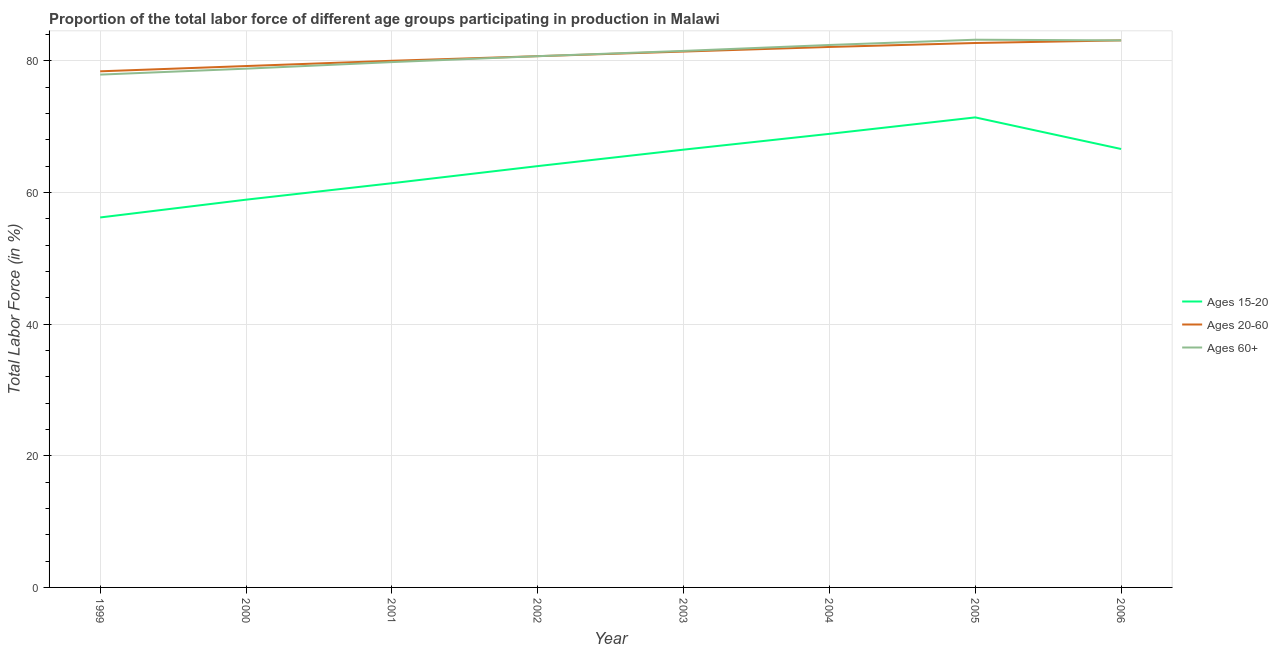How many different coloured lines are there?
Your answer should be very brief. 3. Does the line corresponding to percentage of labor force within the age group 15-20 intersect with the line corresponding to percentage of labor force above age 60?
Make the answer very short. No. What is the percentage of labor force within the age group 15-20 in 2006?
Your response must be concise. 66.6. Across all years, what is the maximum percentage of labor force within the age group 20-60?
Offer a terse response. 83.1. Across all years, what is the minimum percentage of labor force within the age group 20-60?
Your answer should be compact. 78.4. In which year was the percentage of labor force above age 60 maximum?
Your response must be concise. 2005. What is the total percentage of labor force within the age group 20-60 in the graph?
Your response must be concise. 647.6. What is the difference between the percentage of labor force within the age group 20-60 in 2002 and that in 2006?
Provide a short and direct response. -2.4. What is the difference between the percentage of labor force above age 60 in 2006 and the percentage of labor force within the age group 20-60 in 2000?
Make the answer very short. 3.9. What is the average percentage of labor force within the age group 20-60 per year?
Keep it short and to the point. 80.95. What is the ratio of the percentage of labor force within the age group 15-20 in 2000 to that in 2006?
Provide a short and direct response. 0.88. Is the difference between the percentage of labor force above age 60 in 2004 and 2005 greater than the difference between the percentage of labor force within the age group 15-20 in 2004 and 2005?
Ensure brevity in your answer.  Yes. What is the difference between the highest and the second highest percentage of labor force above age 60?
Offer a very short reply. 0.1. What is the difference between the highest and the lowest percentage of labor force above age 60?
Keep it short and to the point. 5.3. Is it the case that in every year, the sum of the percentage of labor force within the age group 15-20 and percentage of labor force within the age group 20-60 is greater than the percentage of labor force above age 60?
Make the answer very short. Yes. Does the percentage of labor force within the age group 15-20 monotonically increase over the years?
Provide a short and direct response. No. Is the percentage of labor force within the age group 15-20 strictly greater than the percentage of labor force above age 60 over the years?
Your answer should be very brief. No. How many lines are there?
Offer a very short reply. 3. How many years are there in the graph?
Make the answer very short. 8. Are the values on the major ticks of Y-axis written in scientific E-notation?
Make the answer very short. No. Does the graph contain any zero values?
Your response must be concise. No. Does the graph contain grids?
Offer a terse response. Yes. How are the legend labels stacked?
Make the answer very short. Vertical. What is the title of the graph?
Offer a very short reply. Proportion of the total labor force of different age groups participating in production in Malawi. Does "Refusal of sex" appear as one of the legend labels in the graph?
Keep it short and to the point. No. What is the Total Labor Force (in %) in Ages 15-20 in 1999?
Make the answer very short. 56.2. What is the Total Labor Force (in %) of Ages 20-60 in 1999?
Your answer should be compact. 78.4. What is the Total Labor Force (in %) of Ages 60+ in 1999?
Your response must be concise. 77.9. What is the Total Labor Force (in %) of Ages 15-20 in 2000?
Offer a very short reply. 58.9. What is the Total Labor Force (in %) of Ages 20-60 in 2000?
Give a very brief answer. 79.2. What is the Total Labor Force (in %) in Ages 60+ in 2000?
Your answer should be compact. 78.8. What is the Total Labor Force (in %) in Ages 15-20 in 2001?
Your answer should be compact. 61.4. What is the Total Labor Force (in %) of Ages 60+ in 2001?
Give a very brief answer. 79.8. What is the Total Labor Force (in %) of Ages 20-60 in 2002?
Your answer should be very brief. 80.7. What is the Total Labor Force (in %) in Ages 60+ in 2002?
Give a very brief answer. 80.7. What is the Total Labor Force (in %) of Ages 15-20 in 2003?
Offer a very short reply. 66.5. What is the Total Labor Force (in %) in Ages 20-60 in 2003?
Provide a short and direct response. 81.4. What is the Total Labor Force (in %) of Ages 60+ in 2003?
Keep it short and to the point. 81.5. What is the Total Labor Force (in %) in Ages 15-20 in 2004?
Your response must be concise. 68.9. What is the Total Labor Force (in %) of Ages 20-60 in 2004?
Your response must be concise. 82.1. What is the Total Labor Force (in %) in Ages 60+ in 2004?
Your answer should be very brief. 82.4. What is the Total Labor Force (in %) in Ages 15-20 in 2005?
Your response must be concise. 71.4. What is the Total Labor Force (in %) of Ages 20-60 in 2005?
Offer a terse response. 82.7. What is the Total Labor Force (in %) of Ages 60+ in 2005?
Your answer should be compact. 83.2. What is the Total Labor Force (in %) in Ages 15-20 in 2006?
Ensure brevity in your answer.  66.6. What is the Total Labor Force (in %) in Ages 20-60 in 2006?
Your answer should be very brief. 83.1. What is the Total Labor Force (in %) in Ages 60+ in 2006?
Your response must be concise. 83.1. Across all years, what is the maximum Total Labor Force (in %) of Ages 15-20?
Give a very brief answer. 71.4. Across all years, what is the maximum Total Labor Force (in %) in Ages 20-60?
Make the answer very short. 83.1. Across all years, what is the maximum Total Labor Force (in %) in Ages 60+?
Provide a succinct answer. 83.2. Across all years, what is the minimum Total Labor Force (in %) of Ages 15-20?
Your response must be concise. 56.2. Across all years, what is the minimum Total Labor Force (in %) in Ages 20-60?
Keep it short and to the point. 78.4. Across all years, what is the minimum Total Labor Force (in %) of Ages 60+?
Keep it short and to the point. 77.9. What is the total Total Labor Force (in %) of Ages 15-20 in the graph?
Make the answer very short. 513.9. What is the total Total Labor Force (in %) in Ages 20-60 in the graph?
Offer a terse response. 647.6. What is the total Total Labor Force (in %) of Ages 60+ in the graph?
Keep it short and to the point. 647.4. What is the difference between the Total Labor Force (in %) of Ages 20-60 in 1999 and that in 2000?
Keep it short and to the point. -0.8. What is the difference between the Total Labor Force (in %) in Ages 60+ in 1999 and that in 2000?
Ensure brevity in your answer.  -0.9. What is the difference between the Total Labor Force (in %) of Ages 15-20 in 1999 and that in 2001?
Your response must be concise. -5.2. What is the difference between the Total Labor Force (in %) of Ages 20-60 in 1999 and that in 2001?
Ensure brevity in your answer.  -1.6. What is the difference between the Total Labor Force (in %) in Ages 15-20 in 1999 and that in 2002?
Your answer should be compact. -7.8. What is the difference between the Total Labor Force (in %) in Ages 60+ in 1999 and that in 2002?
Your response must be concise. -2.8. What is the difference between the Total Labor Force (in %) in Ages 15-20 in 1999 and that in 2003?
Provide a succinct answer. -10.3. What is the difference between the Total Labor Force (in %) in Ages 20-60 in 1999 and that in 2003?
Make the answer very short. -3. What is the difference between the Total Labor Force (in %) in Ages 60+ in 1999 and that in 2003?
Ensure brevity in your answer.  -3.6. What is the difference between the Total Labor Force (in %) in Ages 15-20 in 1999 and that in 2004?
Keep it short and to the point. -12.7. What is the difference between the Total Labor Force (in %) in Ages 15-20 in 1999 and that in 2005?
Make the answer very short. -15.2. What is the difference between the Total Labor Force (in %) of Ages 15-20 in 1999 and that in 2006?
Offer a very short reply. -10.4. What is the difference between the Total Labor Force (in %) in Ages 20-60 in 2000 and that in 2001?
Keep it short and to the point. -0.8. What is the difference between the Total Labor Force (in %) of Ages 15-20 in 2000 and that in 2002?
Provide a short and direct response. -5.1. What is the difference between the Total Labor Force (in %) of Ages 20-60 in 2000 and that in 2002?
Your answer should be very brief. -1.5. What is the difference between the Total Labor Force (in %) in Ages 15-20 in 2000 and that in 2003?
Give a very brief answer. -7.6. What is the difference between the Total Labor Force (in %) in Ages 20-60 in 2000 and that in 2003?
Offer a very short reply. -2.2. What is the difference between the Total Labor Force (in %) in Ages 15-20 in 2000 and that in 2004?
Ensure brevity in your answer.  -10. What is the difference between the Total Labor Force (in %) in Ages 20-60 in 2000 and that in 2004?
Ensure brevity in your answer.  -2.9. What is the difference between the Total Labor Force (in %) in Ages 15-20 in 2000 and that in 2005?
Offer a terse response. -12.5. What is the difference between the Total Labor Force (in %) in Ages 15-20 in 2000 and that in 2006?
Your answer should be compact. -7.7. What is the difference between the Total Labor Force (in %) of Ages 20-60 in 2000 and that in 2006?
Provide a short and direct response. -3.9. What is the difference between the Total Labor Force (in %) of Ages 60+ in 2000 and that in 2006?
Your response must be concise. -4.3. What is the difference between the Total Labor Force (in %) in Ages 15-20 in 2001 and that in 2002?
Keep it short and to the point. -2.6. What is the difference between the Total Labor Force (in %) in Ages 60+ in 2001 and that in 2002?
Your answer should be very brief. -0.9. What is the difference between the Total Labor Force (in %) of Ages 15-20 in 2001 and that in 2003?
Offer a very short reply. -5.1. What is the difference between the Total Labor Force (in %) of Ages 20-60 in 2001 and that in 2003?
Your answer should be compact. -1.4. What is the difference between the Total Labor Force (in %) of Ages 20-60 in 2001 and that in 2005?
Make the answer very short. -2.7. What is the difference between the Total Labor Force (in %) in Ages 15-20 in 2001 and that in 2006?
Your answer should be compact. -5.2. What is the difference between the Total Labor Force (in %) of Ages 20-60 in 2002 and that in 2003?
Offer a terse response. -0.7. What is the difference between the Total Labor Force (in %) of Ages 20-60 in 2002 and that in 2004?
Your answer should be very brief. -1.4. What is the difference between the Total Labor Force (in %) in Ages 60+ in 2002 and that in 2004?
Provide a succinct answer. -1.7. What is the difference between the Total Labor Force (in %) of Ages 20-60 in 2002 and that in 2005?
Offer a very short reply. -2. What is the difference between the Total Labor Force (in %) of Ages 60+ in 2002 and that in 2005?
Ensure brevity in your answer.  -2.5. What is the difference between the Total Labor Force (in %) of Ages 20-60 in 2002 and that in 2006?
Keep it short and to the point. -2.4. What is the difference between the Total Labor Force (in %) in Ages 60+ in 2003 and that in 2004?
Offer a terse response. -0.9. What is the difference between the Total Labor Force (in %) of Ages 20-60 in 2003 and that in 2005?
Offer a very short reply. -1.3. What is the difference between the Total Labor Force (in %) of Ages 60+ in 2003 and that in 2005?
Make the answer very short. -1.7. What is the difference between the Total Labor Force (in %) in Ages 15-20 in 2003 and that in 2006?
Your answer should be very brief. -0.1. What is the difference between the Total Labor Force (in %) in Ages 20-60 in 2003 and that in 2006?
Make the answer very short. -1.7. What is the difference between the Total Labor Force (in %) of Ages 20-60 in 2004 and that in 2005?
Offer a very short reply. -0.6. What is the difference between the Total Labor Force (in %) of Ages 15-20 in 2004 and that in 2006?
Give a very brief answer. 2.3. What is the difference between the Total Labor Force (in %) of Ages 60+ in 2004 and that in 2006?
Keep it short and to the point. -0.7. What is the difference between the Total Labor Force (in %) in Ages 15-20 in 2005 and that in 2006?
Provide a succinct answer. 4.8. What is the difference between the Total Labor Force (in %) of Ages 20-60 in 2005 and that in 2006?
Offer a very short reply. -0.4. What is the difference between the Total Labor Force (in %) in Ages 60+ in 2005 and that in 2006?
Offer a terse response. 0.1. What is the difference between the Total Labor Force (in %) of Ages 15-20 in 1999 and the Total Labor Force (in %) of Ages 20-60 in 2000?
Make the answer very short. -23. What is the difference between the Total Labor Force (in %) in Ages 15-20 in 1999 and the Total Labor Force (in %) in Ages 60+ in 2000?
Provide a succinct answer. -22.6. What is the difference between the Total Labor Force (in %) of Ages 15-20 in 1999 and the Total Labor Force (in %) of Ages 20-60 in 2001?
Offer a very short reply. -23.8. What is the difference between the Total Labor Force (in %) in Ages 15-20 in 1999 and the Total Labor Force (in %) in Ages 60+ in 2001?
Make the answer very short. -23.6. What is the difference between the Total Labor Force (in %) in Ages 15-20 in 1999 and the Total Labor Force (in %) in Ages 20-60 in 2002?
Provide a short and direct response. -24.5. What is the difference between the Total Labor Force (in %) of Ages 15-20 in 1999 and the Total Labor Force (in %) of Ages 60+ in 2002?
Offer a terse response. -24.5. What is the difference between the Total Labor Force (in %) of Ages 20-60 in 1999 and the Total Labor Force (in %) of Ages 60+ in 2002?
Give a very brief answer. -2.3. What is the difference between the Total Labor Force (in %) of Ages 15-20 in 1999 and the Total Labor Force (in %) of Ages 20-60 in 2003?
Provide a succinct answer. -25.2. What is the difference between the Total Labor Force (in %) in Ages 15-20 in 1999 and the Total Labor Force (in %) in Ages 60+ in 2003?
Keep it short and to the point. -25.3. What is the difference between the Total Labor Force (in %) in Ages 15-20 in 1999 and the Total Labor Force (in %) in Ages 20-60 in 2004?
Give a very brief answer. -25.9. What is the difference between the Total Labor Force (in %) in Ages 15-20 in 1999 and the Total Labor Force (in %) in Ages 60+ in 2004?
Provide a short and direct response. -26.2. What is the difference between the Total Labor Force (in %) in Ages 15-20 in 1999 and the Total Labor Force (in %) in Ages 20-60 in 2005?
Make the answer very short. -26.5. What is the difference between the Total Labor Force (in %) in Ages 15-20 in 1999 and the Total Labor Force (in %) in Ages 60+ in 2005?
Your response must be concise. -27. What is the difference between the Total Labor Force (in %) in Ages 15-20 in 1999 and the Total Labor Force (in %) in Ages 20-60 in 2006?
Keep it short and to the point. -26.9. What is the difference between the Total Labor Force (in %) of Ages 15-20 in 1999 and the Total Labor Force (in %) of Ages 60+ in 2006?
Keep it short and to the point. -26.9. What is the difference between the Total Labor Force (in %) in Ages 20-60 in 1999 and the Total Labor Force (in %) in Ages 60+ in 2006?
Provide a short and direct response. -4.7. What is the difference between the Total Labor Force (in %) in Ages 15-20 in 2000 and the Total Labor Force (in %) in Ages 20-60 in 2001?
Provide a succinct answer. -21.1. What is the difference between the Total Labor Force (in %) in Ages 15-20 in 2000 and the Total Labor Force (in %) in Ages 60+ in 2001?
Provide a short and direct response. -20.9. What is the difference between the Total Labor Force (in %) of Ages 15-20 in 2000 and the Total Labor Force (in %) of Ages 20-60 in 2002?
Give a very brief answer. -21.8. What is the difference between the Total Labor Force (in %) of Ages 15-20 in 2000 and the Total Labor Force (in %) of Ages 60+ in 2002?
Your answer should be very brief. -21.8. What is the difference between the Total Labor Force (in %) in Ages 20-60 in 2000 and the Total Labor Force (in %) in Ages 60+ in 2002?
Your answer should be very brief. -1.5. What is the difference between the Total Labor Force (in %) of Ages 15-20 in 2000 and the Total Labor Force (in %) of Ages 20-60 in 2003?
Your response must be concise. -22.5. What is the difference between the Total Labor Force (in %) in Ages 15-20 in 2000 and the Total Labor Force (in %) in Ages 60+ in 2003?
Your response must be concise. -22.6. What is the difference between the Total Labor Force (in %) of Ages 20-60 in 2000 and the Total Labor Force (in %) of Ages 60+ in 2003?
Offer a very short reply. -2.3. What is the difference between the Total Labor Force (in %) in Ages 15-20 in 2000 and the Total Labor Force (in %) in Ages 20-60 in 2004?
Provide a short and direct response. -23.2. What is the difference between the Total Labor Force (in %) in Ages 15-20 in 2000 and the Total Labor Force (in %) in Ages 60+ in 2004?
Offer a terse response. -23.5. What is the difference between the Total Labor Force (in %) in Ages 15-20 in 2000 and the Total Labor Force (in %) in Ages 20-60 in 2005?
Make the answer very short. -23.8. What is the difference between the Total Labor Force (in %) of Ages 15-20 in 2000 and the Total Labor Force (in %) of Ages 60+ in 2005?
Your answer should be very brief. -24.3. What is the difference between the Total Labor Force (in %) in Ages 15-20 in 2000 and the Total Labor Force (in %) in Ages 20-60 in 2006?
Ensure brevity in your answer.  -24.2. What is the difference between the Total Labor Force (in %) of Ages 15-20 in 2000 and the Total Labor Force (in %) of Ages 60+ in 2006?
Your answer should be compact. -24.2. What is the difference between the Total Labor Force (in %) of Ages 15-20 in 2001 and the Total Labor Force (in %) of Ages 20-60 in 2002?
Your answer should be compact. -19.3. What is the difference between the Total Labor Force (in %) of Ages 15-20 in 2001 and the Total Labor Force (in %) of Ages 60+ in 2002?
Give a very brief answer. -19.3. What is the difference between the Total Labor Force (in %) in Ages 20-60 in 2001 and the Total Labor Force (in %) in Ages 60+ in 2002?
Keep it short and to the point. -0.7. What is the difference between the Total Labor Force (in %) in Ages 15-20 in 2001 and the Total Labor Force (in %) in Ages 60+ in 2003?
Offer a terse response. -20.1. What is the difference between the Total Labor Force (in %) in Ages 15-20 in 2001 and the Total Labor Force (in %) in Ages 20-60 in 2004?
Provide a succinct answer. -20.7. What is the difference between the Total Labor Force (in %) of Ages 15-20 in 2001 and the Total Labor Force (in %) of Ages 20-60 in 2005?
Your response must be concise. -21.3. What is the difference between the Total Labor Force (in %) of Ages 15-20 in 2001 and the Total Labor Force (in %) of Ages 60+ in 2005?
Your response must be concise. -21.8. What is the difference between the Total Labor Force (in %) of Ages 20-60 in 2001 and the Total Labor Force (in %) of Ages 60+ in 2005?
Provide a short and direct response. -3.2. What is the difference between the Total Labor Force (in %) of Ages 15-20 in 2001 and the Total Labor Force (in %) of Ages 20-60 in 2006?
Offer a very short reply. -21.7. What is the difference between the Total Labor Force (in %) of Ages 15-20 in 2001 and the Total Labor Force (in %) of Ages 60+ in 2006?
Keep it short and to the point. -21.7. What is the difference between the Total Labor Force (in %) in Ages 20-60 in 2001 and the Total Labor Force (in %) in Ages 60+ in 2006?
Give a very brief answer. -3.1. What is the difference between the Total Labor Force (in %) in Ages 15-20 in 2002 and the Total Labor Force (in %) in Ages 20-60 in 2003?
Your answer should be compact. -17.4. What is the difference between the Total Labor Force (in %) of Ages 15-20 in 2002 and the Total Labor Force (in %) of Ages 60+ in 2003?
Your response must be concise. -17.5. What is the difference between the Total Labor Force (in %) of Ages 20-60 in 2002 and the Total Labor Force (in %) of Ages 60+ in 2003?
Provide a succinct answer. -0.8. What is the difference between the Total Labor Force (in %) in Ages 15-20 in 2002 and the Total Labor Force (in %) in Ages 20-60 in 2004?
Make the answer very short. -18.1. What is the difference between the Total Labor Force (in %) in Ages 15-20 in 2002 and the Total Labor Force (in %) in Ages 60+ in 2004?
Offer a very short reply. -18.4. What is the difference between the Total Labor Force (in %) in Ages 15-20 in 2002 and the Total Labor Force (in %) in Ages 20-60 in 2005?
Ensure brevity in your answer.  -18.7. What is the difference between the Total Labor Force (in %) of Ages 15-20 in 2002 and the Total Labor Force (in %) of Ages 60+ in 2005?
Your answer should be compact. -19.2. What is the difference between the Total Labor Force (in %) in Ages 15-20 in 2002 and the Total Labor Force (in %) in Ages 20-60 in 2006?
Offer a terse response. -19.1. What is the difference between the Total Labor Force (in %) of Ages 15-20 in 2002 and the Total Labor Force (in %) of Ages 60+ in 2006?
Give a very brief answer. -19.1. What is the difference between the Total Labor Force (in %) in Ages 20-60 in 2002 and the Total Labor Force (in %) in Ages 60+ in 2006?
Keep it short and to the point. -2.4. What is the difference between the Total Labor Force (in %) in Ages 15-20 in 2003 and the Total Labor Force (in %) in Ages 20-60 in 2004?
Keep it short and to the point. -15.6. What is the difference between the Total Labor Force (in %) in Ages 15-20 in 2003 and the Total Labor Force (in %) in Ages 60+ in 2004?
Provide a short and direct response. -15.9. What is the difference between the Total Labor Force (in %) in Ages 20-60 in 2003 and the Total Labor Force (in %) in Ages 60+ in 2004?
Give a very brief answer. -1. What is the difference between the Total Labor Force (in %) in Ages 15-20 in 2003 and the Total Labor Force (in %) in Ages 20-60 in 2005?
Offer a terse response. -16.2. What is the difference between the Total Labor Force (in %) of Ages 15-20 in 2003 and the Total Labor Force (in %) of Ages 60+ in 2005?
Your answer should be very brief. -16.7. What is the difference between the Total Labor Force (in %) in Ages 15-20 in 2003 and the Total Labor Force (in %) in Ages 20-60 in 2006?
Give a very brief answer. -16.6. What is the difference between the Total Labor Force (in %) of Ages 15-20 in 2003 and the Total Labor Force (in %) of Ages 60+ in 2006?
Keep it short and to the point. -16.6. What is the difference between the Total Labor Force (in %) in Ages 20-60 in 2003 and the Total Labor Force (in %) in Ages 60+ in 2006?
Your response must be concise. -1.7. What is the difference between the Total Labor Force (in %) in Ages 15-20 in 2004 and the Total Labor Force (in %) in Ages 60+ in 2005?
Give a very brief answer. -14.3. What is the difference between the Total Labor Force (in %) of Ages 20-60 in 2004 and the Total Labor Force (in %) of Ages 60+ in 2005?
Offer a very short reply. -1.1. What is the difference between the Total Labor Force (in %) in Ages 15-20 in 2004 and the Total Labor Force (in %) in Ages 20-60 in 2006?
Your answer should be very brief. -14.2. What is the difference between the Total Labor Force (in %) of Ages 15-20 in 2004 and the Total Labor Force (in %) of Ages 60+ in 2006?
Keep it short and to the point. -14.2. What is the difference between the Total Labor Force (in %) in Ages 15-20 in 2005 and the Total Labor Force (in %) in Ages 20-60 in 2006?
Your response must be concise. -11.7. What is the difference between the Total Labor Force (in %) of Ages 20-60 in 2005 and the Total Labor Force (in %) of Ages 60+ in 2006?
Your answer should be compact. -0.4. What is the average Total Labor Force (in %) in Ages 15-20 per year?
Your answer should be very brief. 64.24. What is the average Total Labor Force (in %) of Ages 20-60 per year?
Provide a succinct answer. 80.95. What is the average Total Labor Force (in %) in Ages 60+ per year?
Provide a succinct answer. 80.92. In the year 1999, what is the difference between the Total Labor Force (in %) in Ages 15-20 and Total Labor Force (in %) in Ages 20-60?
Give a very brief answer. -22.2. In the year 1999, what is the difference between the Total Labor Force (in %) of Ages 15-20 and Total Labor Force (in %) of Ages 60+?
Offer a terse response. -21.7. In the year 2000, what is the difference between the Total Labor Force (in %) in Ages 15-20 and Total Labor Force (in %) in Ages 20-60?
Ensure brevity in your answer.  -20.3. In the year 2000, what is the difference between the Total Labor Force (in %) of Ages 15-20 and Total Labor Force (in %) of Ages 60+?
Offer a very short reply. -19.9. In the year 2000, what is the difference between the Total Labor Force (in %) in Ages 20-60 and Total Labor Force (in %) in Ages 60+?
Keep it short and to the point. 0.4. In the year 2001, what is the difference between the Total Labor Force (in %) of Ages 15-20 and Total Labor Force (in %) of Ages 20-60?
Provide a succinct answer. -18.6. In the year 2001, what is the difference between the Total Labor Force (in %) in Ages 15-20 and Total Labor Force (in %) in Ages 60+?
Your answer should be very brief. -18.4. In the year 2001, what is the difference between the Total Labor Force (in %) of Ages 20-60 and Total Labor Force (in %) of Ages 60+?
Your response must be concise. 0.2. In the year 2002, what is the difference between the Total Labor Force (in %) of Ages 15-20 and Total Labor Force (in %) of Ages 20-60?
Provide a succinct answer. -16.7. In the year 2002, what is the difference between the Total Labor Force (in %) in Ages 15-20 and Total Labor Force (in %) in Ages 60+?
Keep it short and to the point. -16.7. In the year 2003, what is the difference between the Total Labor Force (in %) in Ages 15-20 and Total Labor Force (in %) in Ages 20-60?
Offer a terse response. -14.9. In the year 2004, what is the difference between the Total Labor Force (in %) in Ages 15-20 and Total Labor Force (in %) in Ages 60+?
Make the answer very short. -13.5. In the year 2005, what is the difference between the Total Labor Force (in %) in Ages 15-20 and Total Labor Force (in %) in Ages 20-60?
Your answer should be very brief. -11.3. In the year 2005, what is the difference between the Total Labor Force (in %) in Ages 15-20 and Total Labor Force (in %) in Ages 60+?
Your response must be concise. -11.8. In the year 2006, what is the difference between the Total Labor Force (in %) of Ages 15-20 and Total Labor Force (in %) of Ages 20-60?
Give a very brief answer. -16.5. In the year 2006, what is the difference between the Total Labor Force (in %) of Ages 15-20 and Total Labor Force (in %) of Ages 60+?
Provide a succinct answer. -16.5. In the year 2006, what is the difference between the Total Labor Force (in %) of Ages 20-60 and Total Labor Force (in %) of Ages 60+?
Give a very brief answer. 0. What is the ratio of the Total Labor Force (in %) in Ages 15-20 in 1999 to that in 2000?
Make the answer very short. 0.95. What is the ratio of the Total Labor Force (in %) of Ages 15-20 in 1999 to that in 2001?
Keep it short and to the point. 0.92. What is the ratio of the Total Labor Force (in %) in Ages 20-60 in 1999 to that in 2001?
Your answer should be compact. 0.98. What is the ratio of the Total Labor Force (in %) in Ages 60+ in 1999 to that in 2001?
Your answer should be compact. 0.98. What is the ratio of the Total Labor Force (in %) of Ages 15-20 in 1999 to that in 2002?
Your response must be concise. 0.88. What is the ratio of the Total Labor Force (in %) in Ages 20-60 in 1999 to that in 2002?
Your response must be concise. 0.97. What is the ratio of the Total Labor Force (in %) in Ages 60+ in 1999 to that in 2002?
Offer a terse response. 0.97. What is the ratio of the Total Labor Force (in %) of Ages 15-20 in 1999 to that in 2003?
Keep it short and to the point. 0.85. What is the ratio of the Total Labor Force (in %) in Ages 20-60 in 1999 to that in 2003?
Your response must be concise. 0.96. What is the ratio of the Total Labor Force (in %) in Ages 60+ in 1999 to that in 2003?
Your answer should be compact. 0.96. What is the ratio of the Total Labor Force (in %) in Ages 15-20 in 1999 to that in 2004?
Offer a terse response. 0.82. What is the ratio of the Total Labor Force (in %) of Ages 20-60 in 1999 to that in 2004?
Provide a short and direct response. 0.95. What is the ratio of the Total Labor Force (in %) in Ages 60+ in 1999 to that in 2004?
Offer a very short reply. 0.95. What is the ratio of the Total Labor Force (in %) in Ages 15-20 in 1999 to that in 2005?
Keep it short and to the point. 0.79. What is the ratio of the Total Labor Force (in %) of Ages 20-60 in 1999 to that in 2005?
Provide a succinct answer. 0.95. What is the ratio of the Total Labor Force (in %) in Ages 60+ in 1999 to that in 2005?
Make the answer very short. 0.94. What is the ratio of the Total Labor Force (in %) in Ages 15-20 in 1999 to that in 2006?
Give a very brief answer. 0.84. What is the ratio of the Total Labor Force (in %) in Ages 20-60 in 1999 to that in 2006?
Offer a terse response. 0.94. What is the ratio of the Total Labor Force (in %) of Ages 60+ in 1999 to that in 2006?
Make the answer very short. 0.94. What is the ratio of the Total Labor Force (in %) in Ages 15-20 in 2000 to that in 2001?
Your response must be concise. 0.96. What is the ratio of the Total Labor Force (in %) in Ages 20-60 in 2000 to that in 2001?
Offer a very short reply. 0.99. What is the ratio of the Total Labor Force (in %) in Ages 60+ in 2000 to that in 2001?
Your answer should be very brief. 0.99. What is the ratio of the Total Labor Force (in %) in Ages 15-20 in 2000 to that in 2002?
Offer a terse response. 0.92. What is the ratio of the Total Labor Force (in %) in Ages 20-60 in 2000 to that in 2002?
Your answer should be compact. 0.98. What is the ratio of the Total Labor Force (in %) in Ages 60+ in 2000 to that in 2002?
Provide a short and direct response. 0.98. What is the ratio of the Total Labor Force (in %) of Ages 15-20 in 2000 to that in 2003?
Your answer should be compact. 0.89. What is the ratio of the Total Labor Force (in %) in Ages 20-60 in 2000 to that in 2003?
Ensure brevity in your answer.  0.97. What is the ratio of the Total Labor Force (in %) in Ages 60+ in 2000 to that in 2003?
Your answer should be very brief. 0.97. What is the ratio of the Total Labor Force (in %) in Ages 15-20 in 2000 to that in 2004?
Your answer should be compact. 0.85. What is the ratio of the Total Labor Force (in %) in Ages 20-60 in 2000 to that in 2004?
Your answer should be very brief. 0.96. What is the ratio of the Total Labor Force (in %) in Ages 60+ in 2000 to that in 2004?
Offer a terse response. 0.96. What is the ratio of the Total Labor Force (in %) in Ages 15-20 in 2000 to that in 2005?
Provide a succinct answer. 0.82. What is the ratio of the Total Labor Force (in %) of Ages 20-60 in 2000 to that in 2005?
Keep it short and to the point. 0.96. What is the ratio of the Total Labor Force (in %) of Ages 60+ in 2000 to that in 2005?
Your answer should be very brief. 0.95. What is the ratio of the Total Labor Force (in %) in Ages 15-20 in 2000 to that in 2006?
Make the answer very short. 0.88. What is the ratio of the Total Labor Force (in %) in Ages 20-60 in 2000 to that in 2006?
Give a very brief answer. 0.95. What is the ratio of the Total Labor Force (in %) of Ages 60+ in 2000 to that in 2006?
Provide a short and direct response. 0.95. What is the ratio of the Total Labor Force (in %) of Ages 15-20 in 2001 to that in 2002?
Make the answer very short. 0.96. What is the ratio of the Total Labor Force (in %) of Ages 20-60 in 2001 to that in 2002?
Your answer should be very brief. 0.99. What is the ratio of the Total Labor Force (in %) of Ages 15-20 in 2001 to that in 2003?
Offer a very short reply. 0.92. What is the ratio of the Total Labor Force (in %) in Ages 20-60 in 2001 to that in 2003?
Your answer should be compact. 0.98. What is the ratio of the Total Labor Force (in %) in Ages 60+ in 2001 to that in 2003?
Keep it short and to the point. 0.98. What is the ratio of the Total Labor Force (in %) in Ages 15-20 in 2001 to that in 2004?
Provide a succinct answer. 0.89. What is the ratio of the Total Labor Force (in %) of Ages 20-60 in 2001 to that in 2004?
Keep it short and to the point. 0.97. What is the ratio of the Total Labor Force (in %) of Ages 60+ in 2001 to that in 2004?
Keep it short and to the point. 0.97. What is the ratio of the Total Labor Force (in %) of Ages 15-20 in 2001 to that in 2005?
Provide a succinct answer. 0.86. What is the ratio of the Total Labor Force (in %) in Ages 20-60 in 2001 to that in 2005?
Give a very brief answer. 0.97. What is the ratio of the Total Labor Force (in %) of Ages 60+ in 2001 to that in 2005?
Make the answer very short. 0.96. What is the ratio of the Total Labor Force (in %) of Ages 15-20 in 2001 to that in 2006?
Keep it short and to the point. 0.92. What is the ratio of the Total Labor Force (in %) of Ages 20-60 in 2001 to that in 2006?
Offer a very short reply. 0.96. What is the ratio of the Total Labor Force (in %) in Ages 60+ in 2001 to that in 2006?
Offer a terse response. 0.96. What is the ratio of the Total Labor Force (in %) in Ages 15-20 in 2002 to that in 2003?
Provide a short and direct response. 0.96. What is the ratio of the Total Labor Force (in %) in Ages 20-60 in 2002 to that in 2003?
Offer a very short reply. 0.99. What is the ratio of the Total Labor Force (in %) in Ages 60+ in 2002 to that in 2003?
Your response must be concise. 0.99. What is the ratio of the Total Labor Force (in %) of Ages 15-20 in 2002 to that in 2004?
Your response must be concise. 0.93. What is the ratio of the Total Labor Force (in %) of Ages 20-60 in 2002 to that in 2004?
Offer a very short reply. 0.98. What is the ratio of the Total Labor Force (in %) of Ages 60+ in 2002 to that in 2004?
Keep it short and to the point. 0.98. What is the ratio of the Total Labor Force (in %) in Ages 15-20 in 2002 to that in 2005?
Ensure brevity in your answer.  0.9. What is the ratio of the Total Labor Force (in %) in Ages 20-60 in 2002 to that in 2005?
Your response must be concise. 0.98. What is the ratio of the Total Labor Force (in %) of Ages 15-20 in 2002 to that in 2006?
Offer a very short reply. 0.96. What is the ratio of the Total Labor Force (in %) in Ages 20-60 in 2002 to that in 2006?
Provide a short and direct response. 0.97. What is the ratio of the Total Labor Force (in %) of Ages 60+ in 2002 to that in 2006?
Your response must be concise. 0.97. What is the ratio of the Total Labor Force (in %) of Ages 15-20 in 2003 to that in 2004?
Provide a short and direct response. 0.97. What is the ratio of the Total Labor Force (in %) in Ages 15-20 in 2003 to that in 2005?
Make the answer very short. 0.93. What is the ratio of the Total Labor Force (in %) of Ages 20-60 in 2003 to that in 2005?
Make the answer very short. 0.98. What is the ratio of the Total Labor Force (in %) of Ages 60+ in 2003 to that in 2005?
Your answer should be compact. 0.98. What is the ratio of the Total Labor Force (in %) of Ages 20-60 in 2003 to that in 2006?
Offer a very short reply. 0.98. What is the ratio of the Total Labor Force (in %) of Ages 60+ in 2003 to that in 2006?
Your response must be concise. 0.98. What is the ratio of the Total Labor Force (in %) of Ages 20-60 in 2004 to that in 2005?
Give a very brief answer. 0.99. What is the ratio of the Total Labor Force (in %) of Ages 15-20 in 2004 to that in 2006?
Your answer should be compact. 1.03. What is the ratio of the Total Labor Force (in %) in Ages 60+ in 2004 to that in 2006?
Give a very brief answer. 0.99. What is the ratio of the Total Labor Force (in %) of Ages 15-20 in 2005 to that in 2006?
Offer a terse response. 1.07. What is the difference between the highest and the second highest Total Labor Force (in %) of Ages 15-20?
Provide a succinct answer. 2.5. What is the difference between the highest and the lowest Total Labor Force (in %) in Ages 15-20?
Keep it short and to the point. 15.2. What is the difference between the highest and the lowest Total Labor Force (in %) in Ages 60+?
Give a very brief answer. 5.3. 